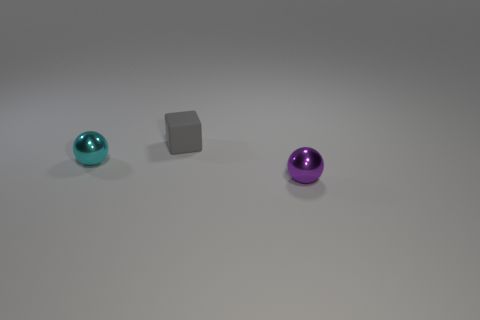How would you classify the lighting in this image? The lighting in the image is soft and diffuse, with no harsh shadows evident. It seems to come from a non-directional source, giving the objects gently defined edges and subtle shadows that suggest an evenly lit indoor setting. 